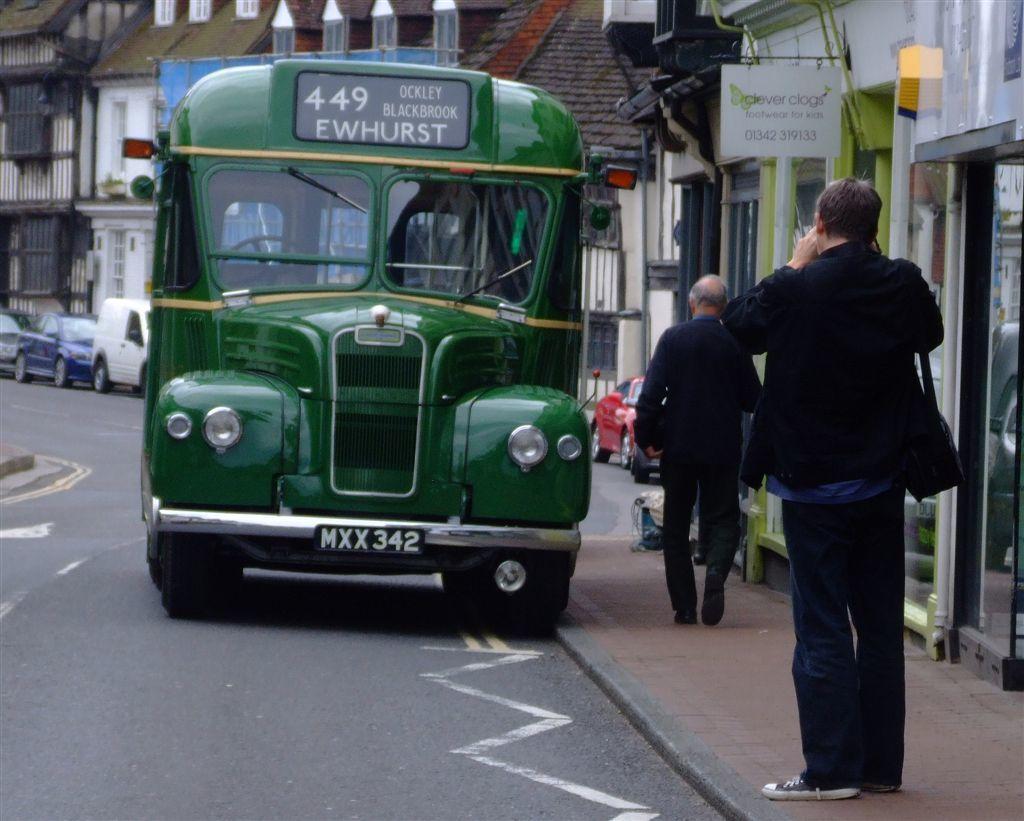What does the license plate say?
Make the answer very short. Mxx342. What number is shown on top?
Offer a very short reply. 449. 